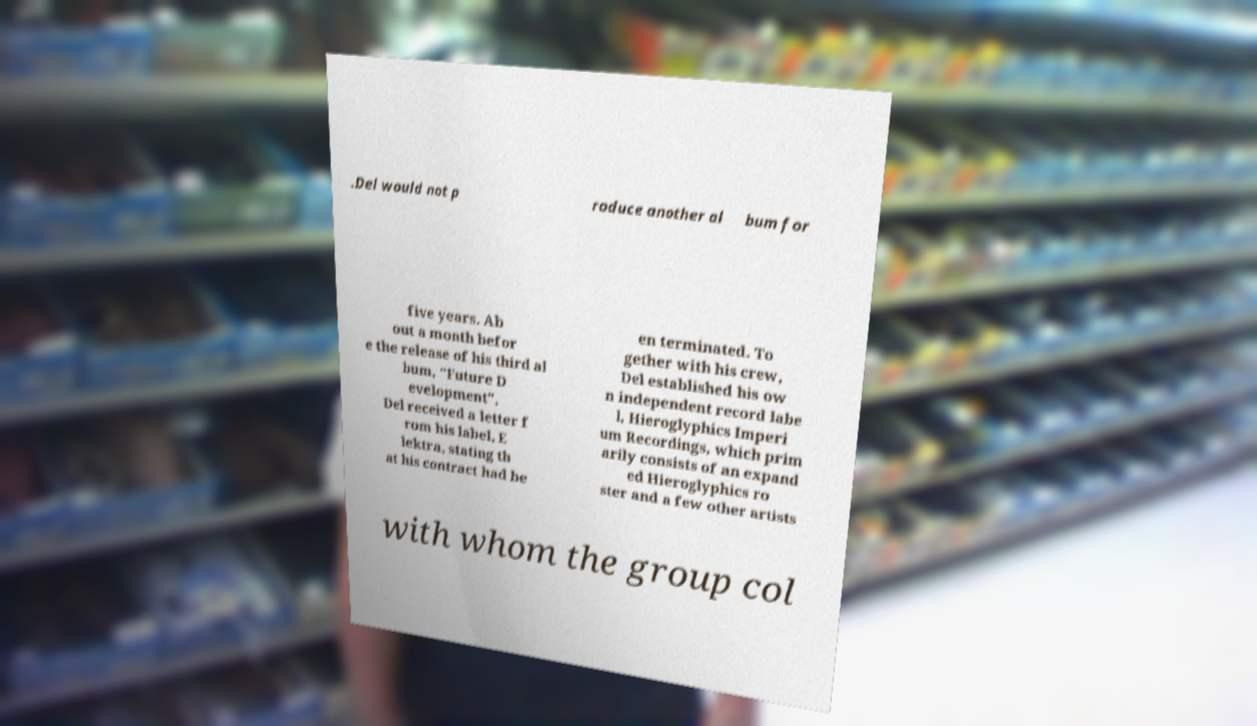For documentation purposes, I need the text within this image transcribed. Could you provide that? .Del would not p roduce another al bum for five years. Ab out a month befor e the release of his third al bum, "Future D evelopment", Del received a letter f rom his label, E lektra, stating th at his contract had be en terminated. To gether with his crew, Del established his ow n independent record labe l, Hieroglyphics Imperi um Recordings, which prim arily consists of an expand ed Hieroglyphics ro ster and a few other artists with whom the group col 